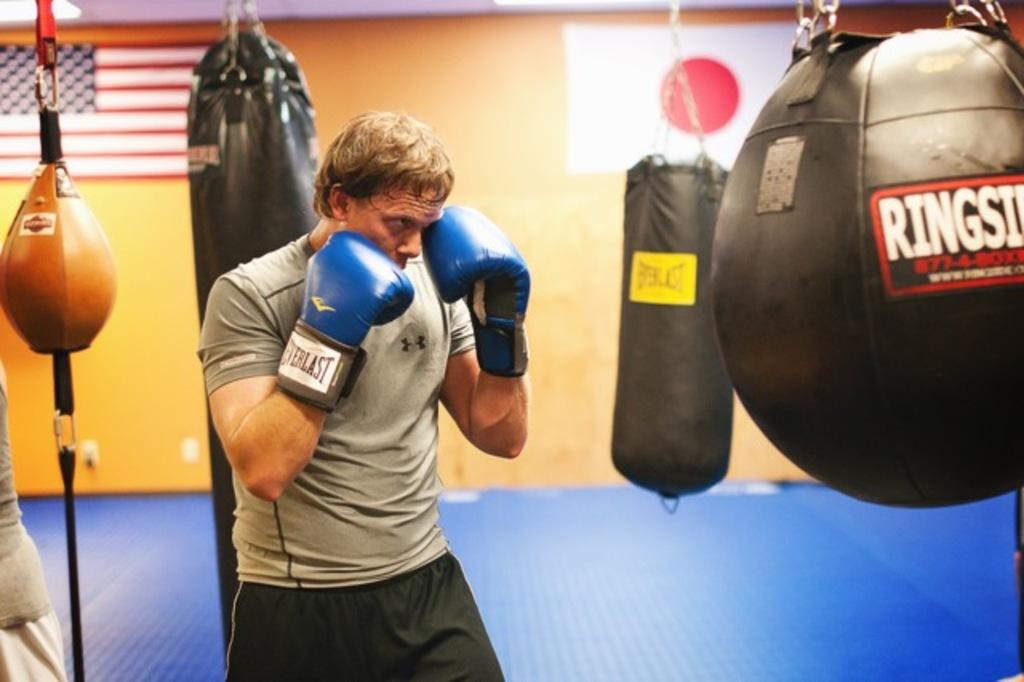What is present in the image? There is a man in the image. What is the man wearing on his hands? The man is wearing gloves. What can be seen on the wall in the background of the image? There are flags on a wall in the background of the image. What type of baseball is the man holding in the image? There is no baseball present in the image. What type of bread is the man using to move around in the image? There is no bread present in the image, and the man is not moving around. 